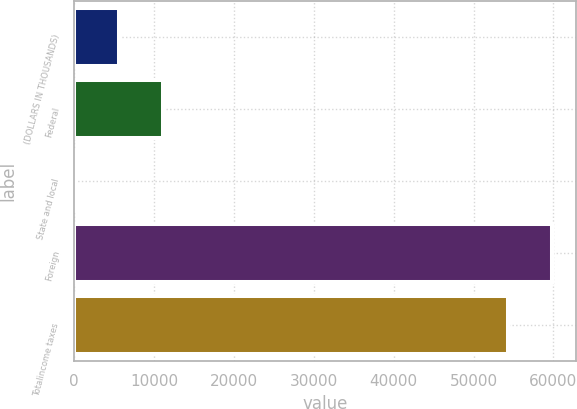Convert chart. <chart><loc_0><loc_0><loc_500><loc_500><bar_chart><fcel>(DOLLARS IN THOUSANDS)<fcel>Federal<fcel>State and local<fcel>Foreign<fcel>Totalincome taxes<nl><fcel>5633.6<fcel>11173.2<fcel>94<fcel>59833.6<fcel>54294<nl></chart> 